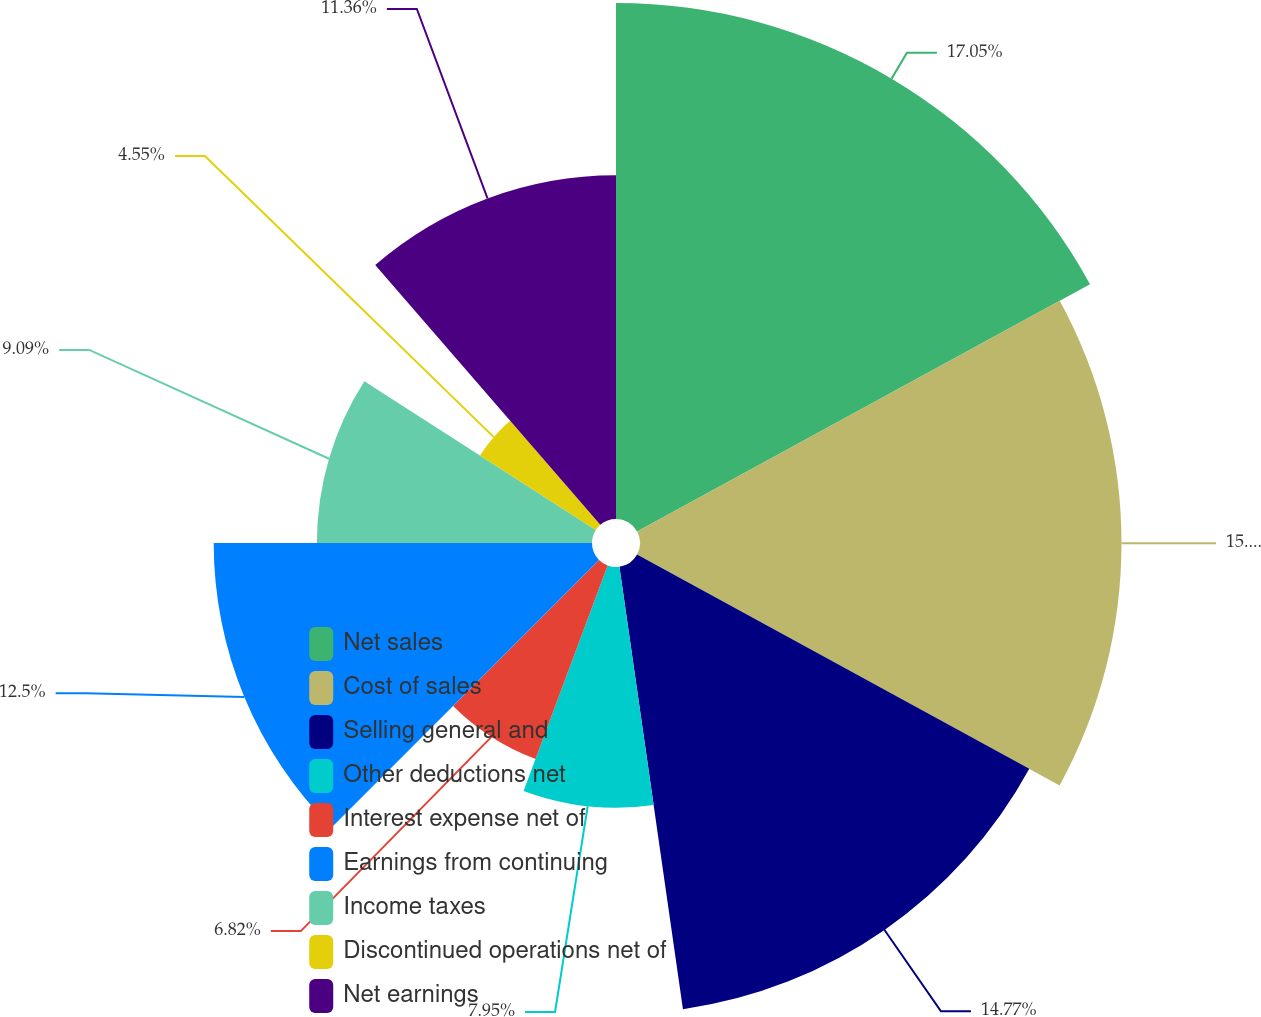Convert chart to OTSL. <chart><loc_0><loc_0><loc_500><loc_500><pie_chart><fcel>Net sales<fcel>Cost of sales<fcel>Selling general and<fcel>Other deductions net<fcel>Interest expense net of<fcel>Earnings from continuing<fcel>Income taxes<fcel>Discontinued operations net of<fcel>Net earnings<nl><fcel>17.05%<fcel>15.91%<fcel>14.77%<fcel>7.95%<fcel>6.82%<fcel>12.5%<fcel>9.09%<fcel>4.55%<fcel>11.36%<nl></chart> 